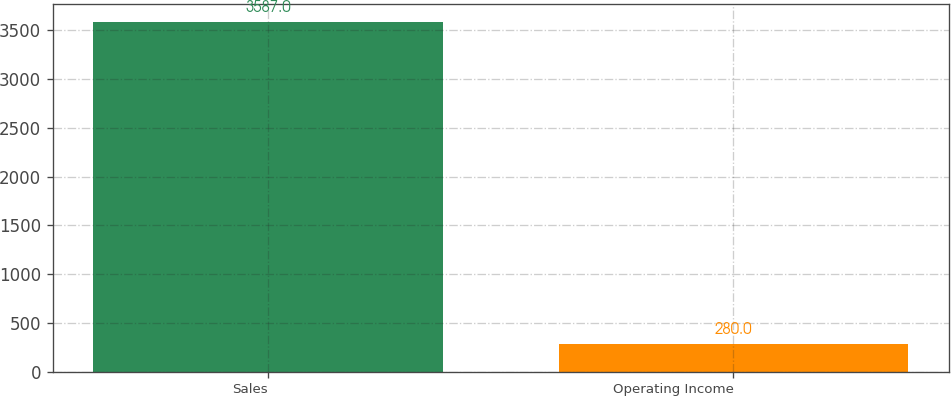Convert chart to OTSL. <chart><loc_0><loc_0><loc_500><loc_500><bar_chart><fcel>Sales<fcel>Operating Income<nl><fcel>3587<fcel>280<nl></chart> 